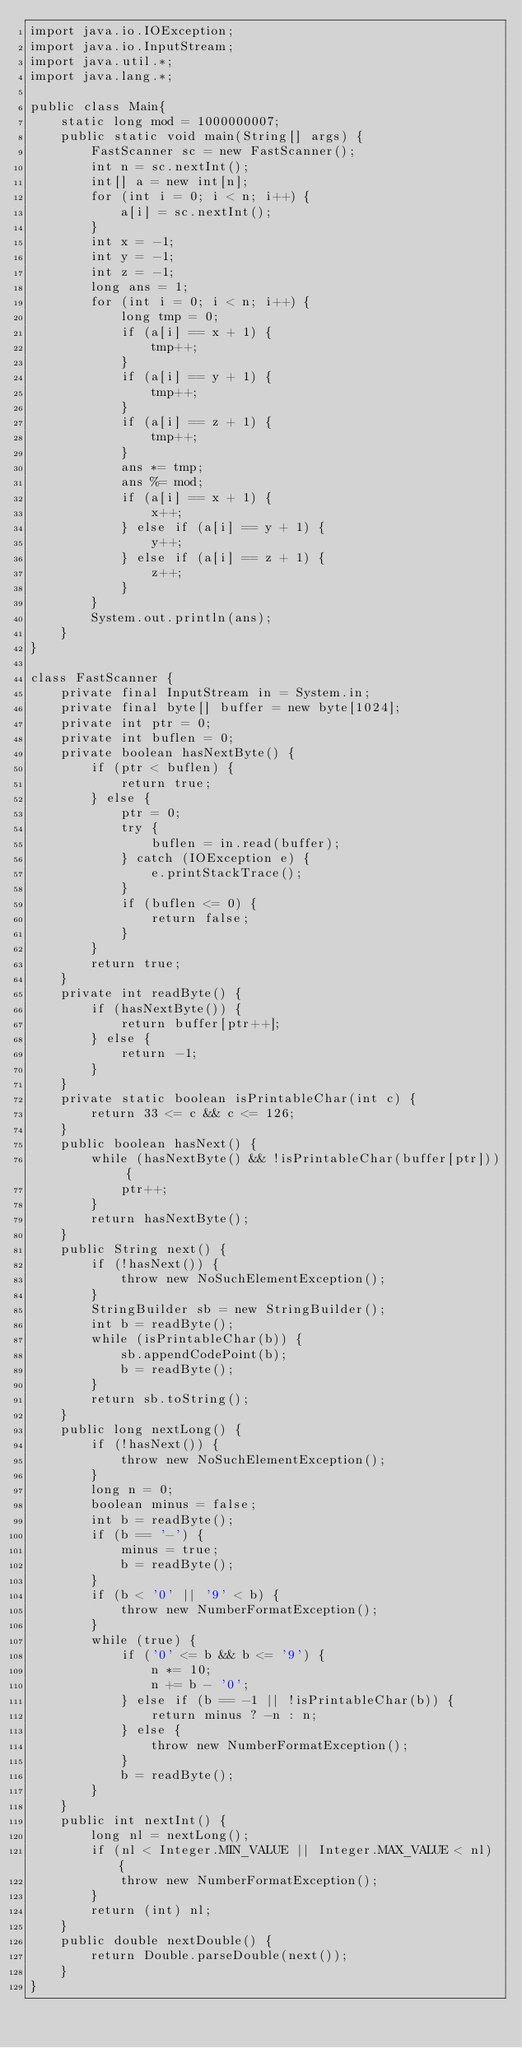<code> <loc_0><loc_0><loc_500><loc_500><_Java_>import java.io.IOException;
import java.io.InputStream;
import java.util.*;
import java.lang.*;

public class Main{
	static long mod = 1000000007;
	public static void main(String[] args) {
		FastScanner sc = new FastScanner();
		int n = sc.nextInt();
		int[] a = new int[n];
		for (int i = 0; i < n; i++) {
			a[i] = sc.nextInt();
		}
		int x = -1;
		int y = -1;
		int z = -1;
		long ans = 1;
		for (int i = 0; i < n; i++) {
			long tmp = 0;
			if (a[i] == x + 1) {
				tmp++;
			}
			if (a[i] == y + 1) {
				tmp++;
			}
			if (a[i] == z + 1) {
				tmp++;
			}
			ans *= tmp;
			ans %= mod;
			if (a[i] == x + 1) {
				x++;
			} else if (a[i] == y + 1) {
				y++;
			} else if (a[i] == z + 1) {
				z++;
			}
		}
		System.out.println(ans);
	}
}

class FastScanner {
	private final InputStream in = System.in;
	private final byte[] buffer = new byte[1024];
	private int ptr = 0;
	private int buflen = 0;
	private boolean hasNextByte() {
		if (ptr < buflen) {
			return true;
		} else {
			ptr = 0;
			try {
				buflen = in.read(buffer);
			} catch (IOException e) {
				e.printStackTrace();
			}
			if (buflen <= 0) {
				return false;
			}
		}
		return true;
	}
	private int readByte() {
		if (hasNextByte()) {
			return buffer[ptr++];
		} else {
			return -1;
		}
	}
	private static boolean isPrintableChar(int c) {
		return 33 <= c && c <= 126;
	}
	public boolean hasNext() {
		while (hasNextByte() && !isPrintableChar(buffer[ptr])) {
			ptr++;
		}
		return hasNextByte();
	}
	public String next() {
		if (!hasNext()) {
			throw new NoSuchElementException();
		}
		StringBuilder sb = new StringBuilder();
		int b = readByte();
		while (isPrintableChar(b)) {
			sb.appendCodePoint(b);
			b = readByte();
		}
		return sb.toString();
	}
	public long nextLong() {
		if (!hasNext()) {
			throw new NoSuchElementException();
		}
		long n = 0;
		boolean minus = false;
		int b = readByte();
		if (b == '-') {
			minus = true;
			b = readByte();
		}
		if (b < '0' || '9' < b) {
			throw new NumberFormatException();
		}
		while (true) {
			if ('0' <= b && b <= '9') {
				n *= 10;
				n += b - '0';
			} else if (b == -1 || !isPrintableChar(b)) {
				return minus ? -n : n;
			} else {
				throw new NumberFormatException();
			}
			b = readByte();
		}
	}
	public int nextInt() {
		long nl = nextLong();
		if (nl < Integer.MIN_VALUE || Integer.MAX_VALUE < nl) {
			throw new NumberFormatException();
		}
		return (int) nl;
	}
	public double nextDouble() {
		return Double.parseDouble(next());
	}
}
</code> 